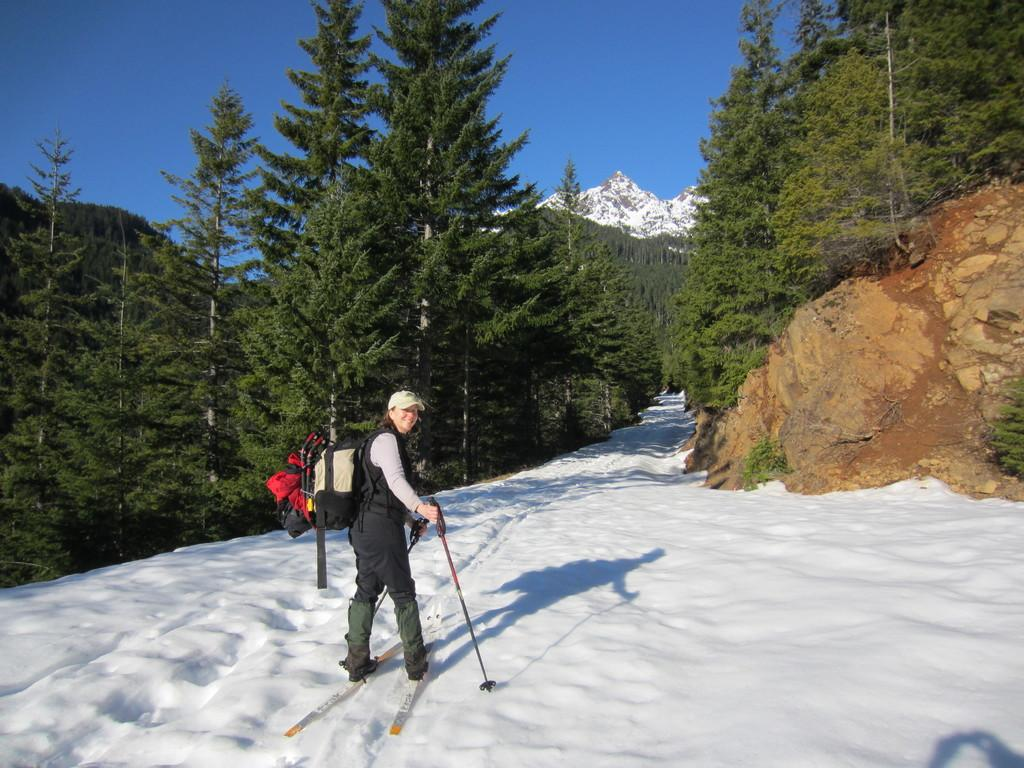Who is the main subject in the image? There is a woman in the image. What is the woman doing in the image? The woman is skiing on the snow. What accessories is the woman wearing in the image? The woman is wearing a bag and a cap. What can be seen in the background of the image? There are trees and hills in the background of the image. What type of nose can be seen on the net in the image? There is no net or nose present in the image; it features a woman skiing on the snow with a bag and a cap. 